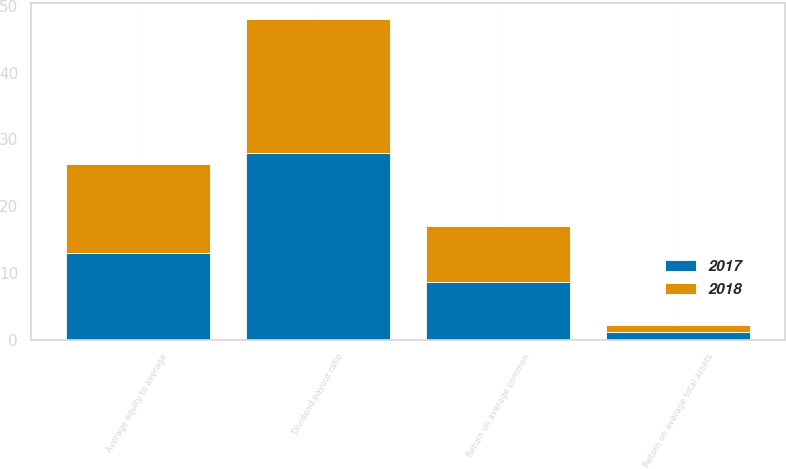Convert chart to OTSL. <chart><loc_0><loc_0><loc_500><loc_500><stacked_bar_chart><ecel><fcel>Return on average total assets<fcel>Return on average common<fcel>Dividend payout ratio<fcel>Average equity to average<nl><fcel>2017<fcel>1.11<fcel>8.62<fcel>28<fcel>13.02<nl><fcel>2018<fcel>1.1<fcel>8.35<fcel>20<fcel>13.25<nl></chart> 